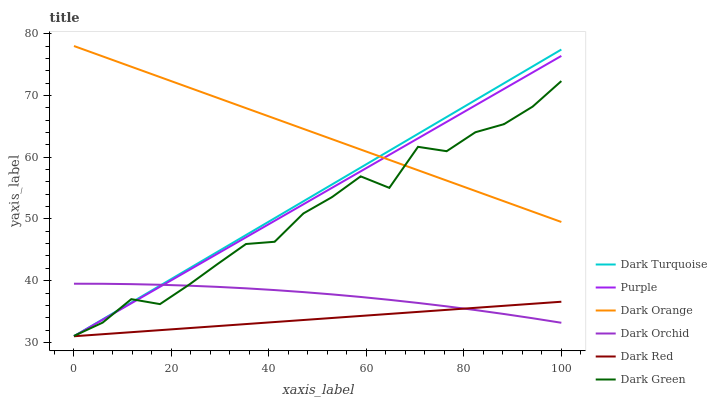Does Dark Red have the minimum area under the curve?
Answer yes or no. Yes. Does Dark Orange have the maximum area under the curve?
Answer yes or no. Yes. Does Purple have the minimum area under the curve?
Answer yes or no. No. Does Purple have the maximum area under the curve?
Answer yes or no. No. Is Dark Red the smoothest?
Answer yes or no. Yes. Is Dark Green the roughest?
Answer yes or no. Yes. Is Purple the smoothest?
Answer yes or no. No. Is Purple the roughest?
Answer yes or no. No. Does Dark Orchid have the lowest value?
Answer yes or no. No. Does Dark Orange have the highest value?
Answer yes or no. Yes. Does Purple have the highest value?
Answer yes or no. No. Is Dark Red less than Dark Orange?
Answer yes or no. Yes. Is Dark Orange greater than Dark Red?
Answer yes or no. Yes. Does Dark Red intersect Dark Orange?
Answer yes or no. No. 